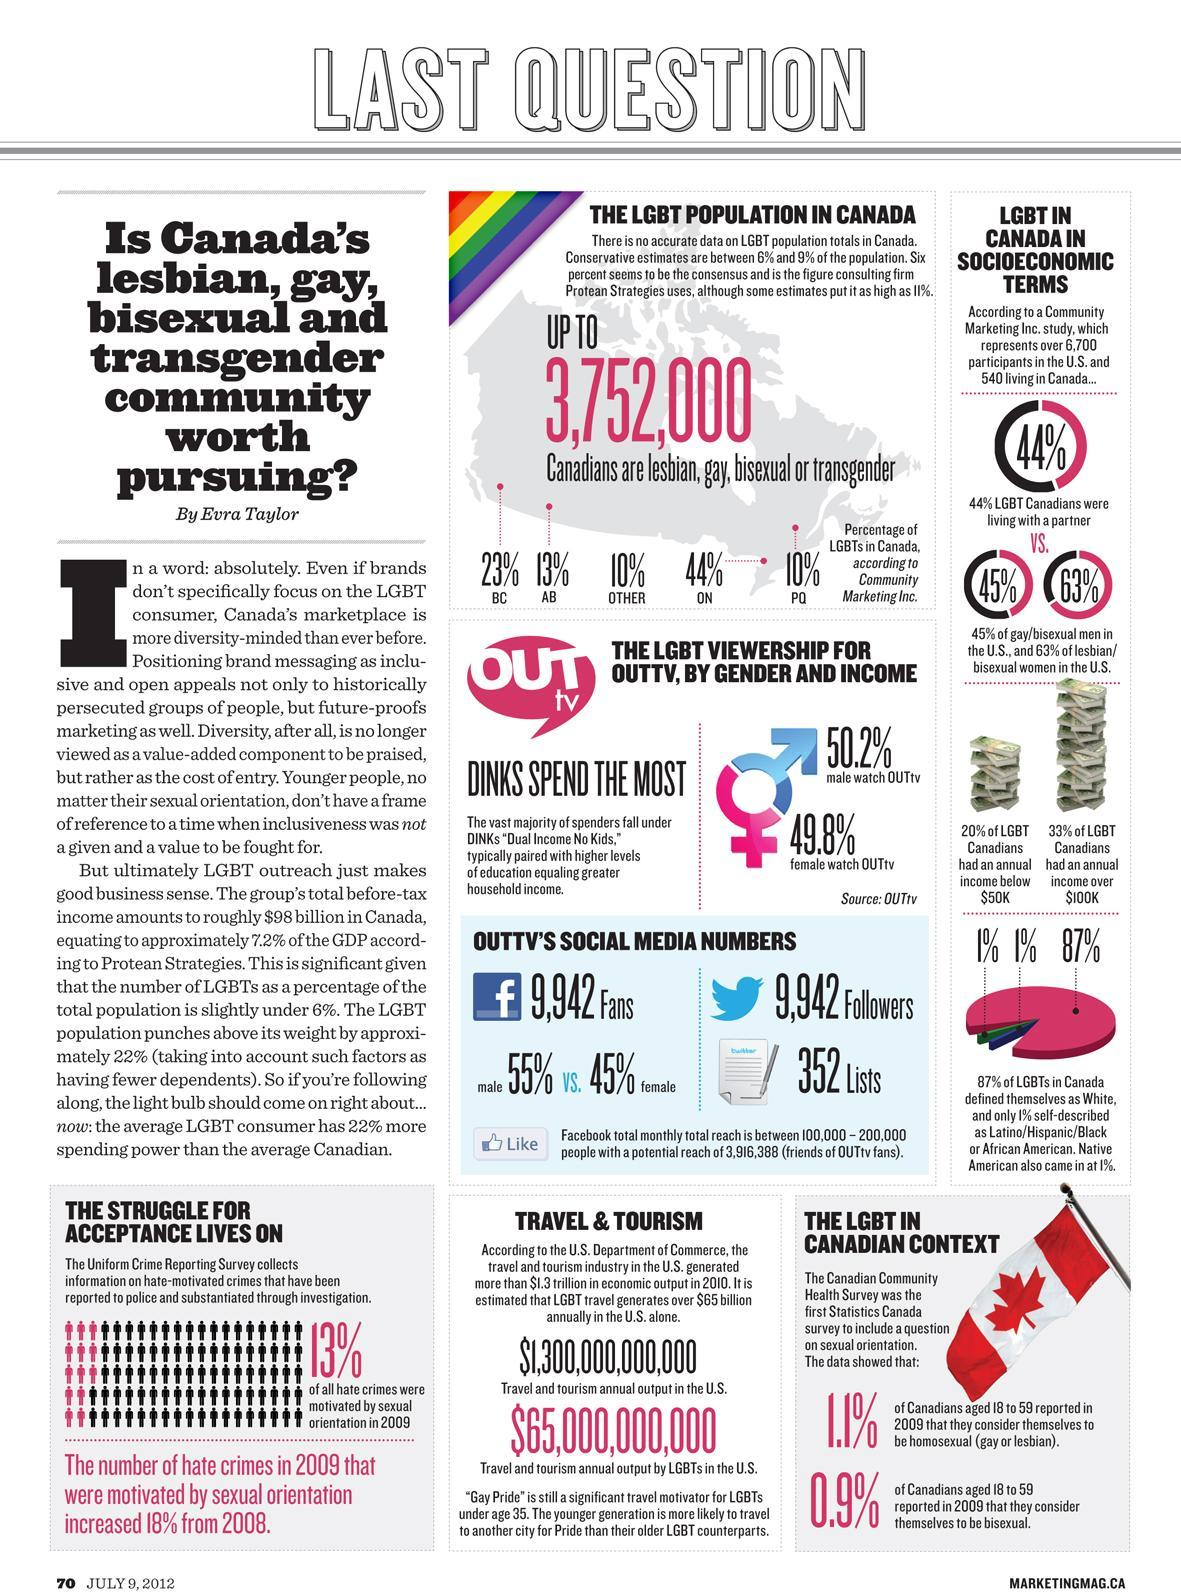Who watches more of OUTtv?
Answer the question with a short phrase. male 